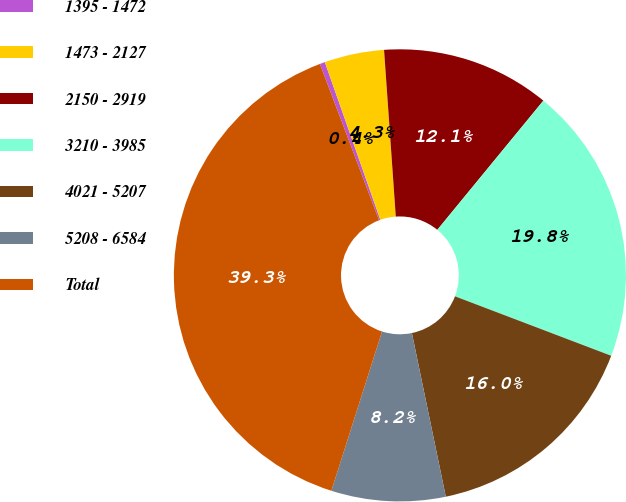<chart> <loc_0><loc_0><loc_500><loc_500><pie_chart><fcel>1395 - 1472<fcel>1473 - 2127<fcel>2150 - 2919<fcel>3210 - 3985<fcel>4021 - 5207<fcel>5208 - 6584<fcel>Total<nl><fcel>0.37%<fcel>4.27%<fcel>12.06%<fcel>19.85%<fcel>15.96%<fcel>8.16%<fcel>39.34%<nl></chart> 